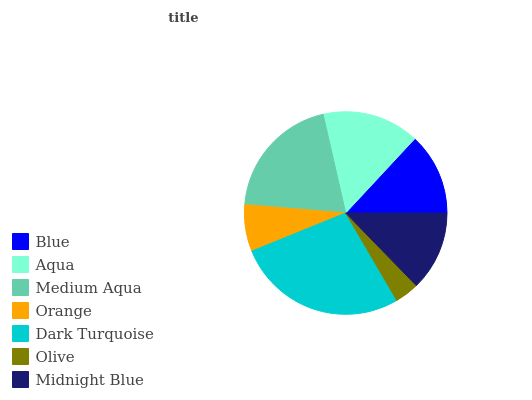Is Olive the minimum?
Answer yes or no. Yes. Is Dark Turquoise the maximum?
Answer yes or no. Yes. Is Aqua the minimum?
Answer yes or no. No. Is Aqua the maximum?
Answer yes or no. No. Is Aqua greater than Blue?
Answer yes or no. Yes. Is Blue less than Aqua?
Answer yes or no. Yes. Is Blue greater than Aqua?
Answer yes or no. No. Is Aqua less than Blue?
Answer yes or no. No. Is Blue the high median?
Answer yes or no. Yes. Is Blue the low median?
Answer yes or no. Yes. Is Medium Aqua the high median?
Answer yes or no. No. Is Orange the low median?
Answer yes or no. No. 